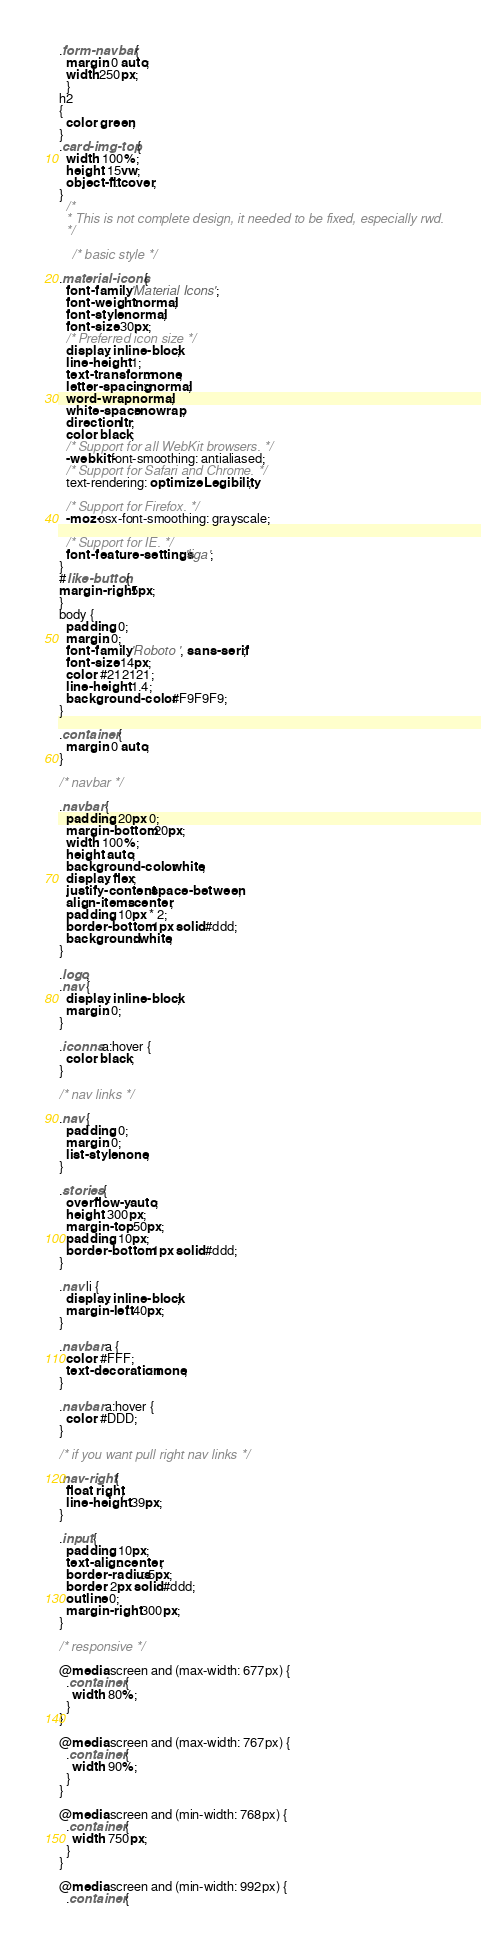<code> <loc_0><loc_0><loc_500><loc_500><_CSS_>.form-navbar { 
  margin: 0 auto; 
  width:250px;
  }
h2
{
  color: green;
}
.card-img-top {
  width: 100%;
  height: 15vw;
  object-fit: cover;
}
  /*
  * This is not complete design, it needed to be fixed, especially rwd.
  */

    /* basic style */

.material-icons {
  font-family: 'Material Icons';
  font-weight: normal;
  font-style: normal;
  font-size: 30px;
  /* Preferred icon size */
  display: inline-block;
  line-height: 1;
  text-transform: none;
  letter-spacing: normal;
  word-wrap: normal;
  white-space: nowrap;
  direction: ltr;
  color: black;
  /* Support for all WebKit browsers. */
  -webkit-font-smoothing: antialiased;
  /* Support for Safari and Chrome. */
  text-rendering: optimizeLegibility;

  /* Support for Firefox. */
  -moz-osx-font-smoothing: grayscale;

  /* Support for IE. */
  font-feature-settings: 'liga';
}
#like-button{
margin-right:5px;
}
body {
  padding: 0;
  margin: 0;
  font-family: 'Roboto ', sans-serif;
  font-size: 14px;
  color: #212121;
  line-height: 1.4;
  background-color: #F9F9F9;
}

.container {
  margin: 0 auto;
}

/* navbar */

.navbar {
  padding: 20px 0;
  margin-bottom: 20px;
  width: 100%;
  height: auto;
  background-color: white;
  display: flex;
  justify-content: space-between;
  align-items: center;
  padding: 10px * 2;
  border-bottom: 1px solid #ddd;
  background: white;
}

.logo,
.nav {
  display: inline-block;
  margin: 0;
}

.iconns a:hover {
  color: black;
}

/* nav links */

.nav {
  padding: 0;
  margin: 0;
  list-style: none;
}

.stories {
  overflow-y: auto;
  height: 300px;
  margin-top: 50px;
  padding: 10px;
  border-bottom: 1px solid #ddd;
}

.nav li {
  display: inline-block;
  margin-left: 40px;
}

.navbar a {
  color: #FFF;
  text-decoration: none;
}

.navbar a:hover {
  color: #DDD;
}

/* if you want pull right nav links */

.nav-right {
  float: right;
  line-height: 39px;
}

.input {
  padding: 10px;
  text-align: center;
  border-radius: 5px;
  border: 2px solid #ddd;
  outline: 0;
  margin-right: 300px;
}

/* responsive */

@media screen and (max-width: 677px) {
  .container {
    width: 80%;
  }
}

@media screen and (max-width: 767px) {
  .container {
    width: 90%;
  }
}

@media screen and (min-width: 768px) {
  .container {
    width: 750px;
  }
}

@media screen and (min-width: 992px) {
  .container {</code> 